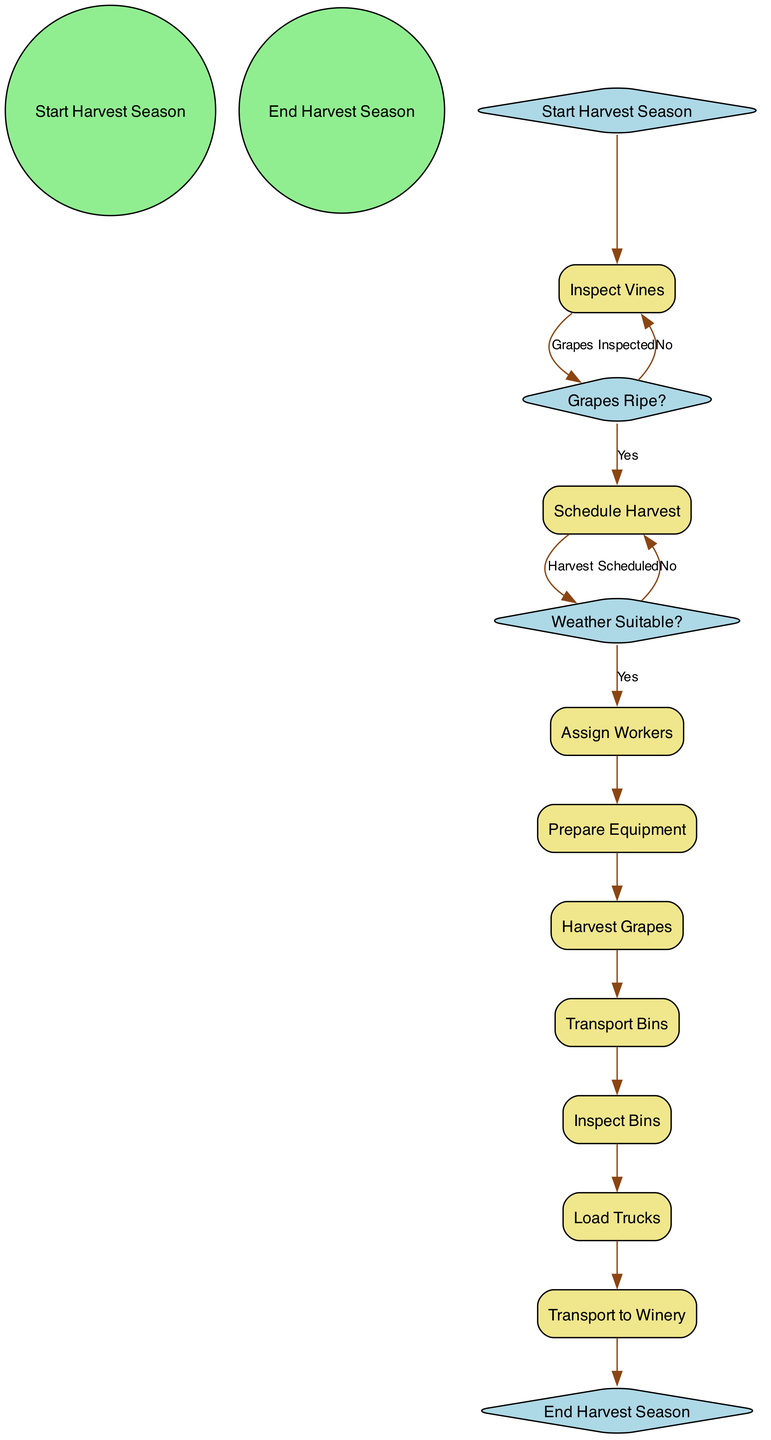What is the starting event in this activity diagram? The starting event is represented by a circle node labeled "Start Harvest Season." This is the initial point from where the activities begin in the diagram.
Answer: Start Harvest Season Which decision follows the "Inspect Vines" activity? After the "Inspect Vines" activity, the next decision point is "Grapes Ripe?" This indicates that the inspection leads to an evaluation of grape ripeness.
Answer: Grapes Ripe? How many activities are there in total? By counting the listed activities in the diagram, there are eight specific actions for managing the vineyard harvest. This does not include decision points or start/end events.
Answer: 8 What happens if the weather is not suitable after scheduling the harvest? If the weather is not suitable, the flow goes back to "Schedule Harvest," indicating that new harvesting days will be selected based on weather conditions.
Answer: Schedule Harvest What is the last activity before the end of the harvest season? The last activity before reaching the end of the harvest season is "Transport to Winery," which involves moving the grapes to the winery for processing.
Answer: Transport to Winery How many decision points are there in the diagram? There are two decision points in the diagram: "Grapes Ripe?" and "Weather Suitable?" Each serves to evaluate conditions before proceeding with the next steps.
Answer: 2 Which activity follows after the workers prepare the equipment? After "Prepare Equipment," the next activity in the sequence is "Harvest Grapes," which entails the actual picking of the grapes.
Answer: Harvest Grapes What is the transition condition from "Assign Workers" to "Prepare Equipment"? The transition from "Assign Workers" to "Prepare Equipment" happens without any specific condition mentioned; it is a direct flow from one activity to the next.
Answer: None 